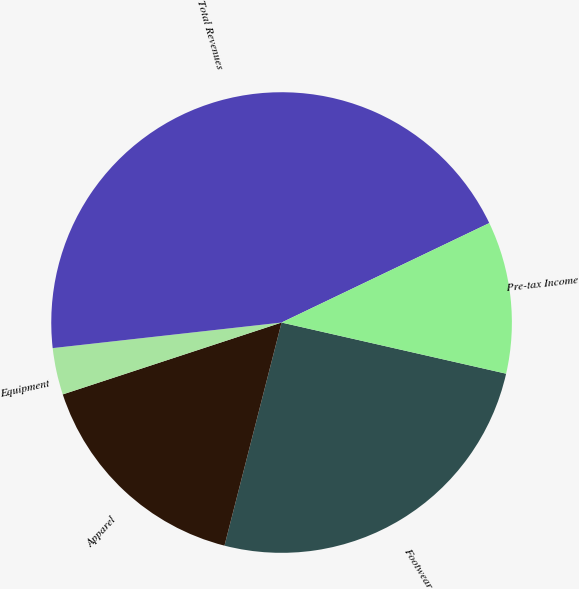<chart> <loc_0><loc_0><loc_500><loc_500><pie_chart><fcel>Footwear<fcel>Apparel<fcel>Equipment<fcel>Total Revenues<fcel>Pre-tax Income<nl><fcel>25.42%<fcel>15.96%<fcel>3.28%<fcel>44.66%<fcel>10.67%<nl></chart> 